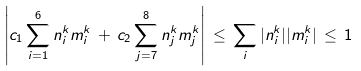<formula> <loc_0><loc_0><loc_500><loc_500>\left | c _ { 1 } \sum _ { i = 1 } ^ { 6 } n _ { i } ^ { k } m _ { i } ^ { k } \, + \, c _ { 2 } \sum _ { j = 7 } ^ { 8 } n _ { j } ^ { k } m _ { j } ^ { k } \right | \, \leq \, \sum _ { i } | n _ { i } ^ { k } | | m _ { i } ^ { k } | \, \leq \, 1</formula> 